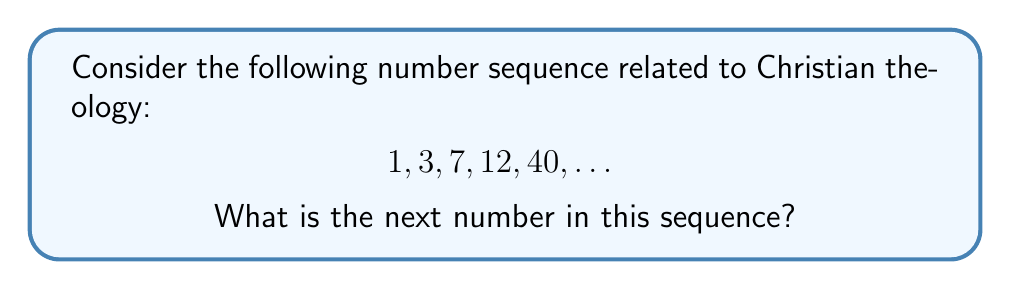Can you answer this question? To determine the pattern in this sequence, let's analyze each number's significance in Christian theology:

1. The number 1 represents the unity of God.
2. The number 3 represents the Holy Trinity (Father, Son, and Holy Spirit).
3. The number 7 represents the seven days of creation.
4. The number 12 represents the twelve apostles of Jesus.
5. The number 40 represents significant periods in the Bible (e.g., 40 days of the flood, 40 years in the wilderness, 40 days of Jesus' temptation).

The pattern appears to be based on significant biblical numbers. The next significant number in this theological sequence would be 50.

The number 50 is important in Christian theology for several reasons:
1. It represents the day of Pentecost, which occurred 50 days after Easter.
2. It symbolizes the Year of Jubilee in the Old Testament, which occurred every 50 years.

Therefore, the next number in the sequence should be 50.
Answer: 50 